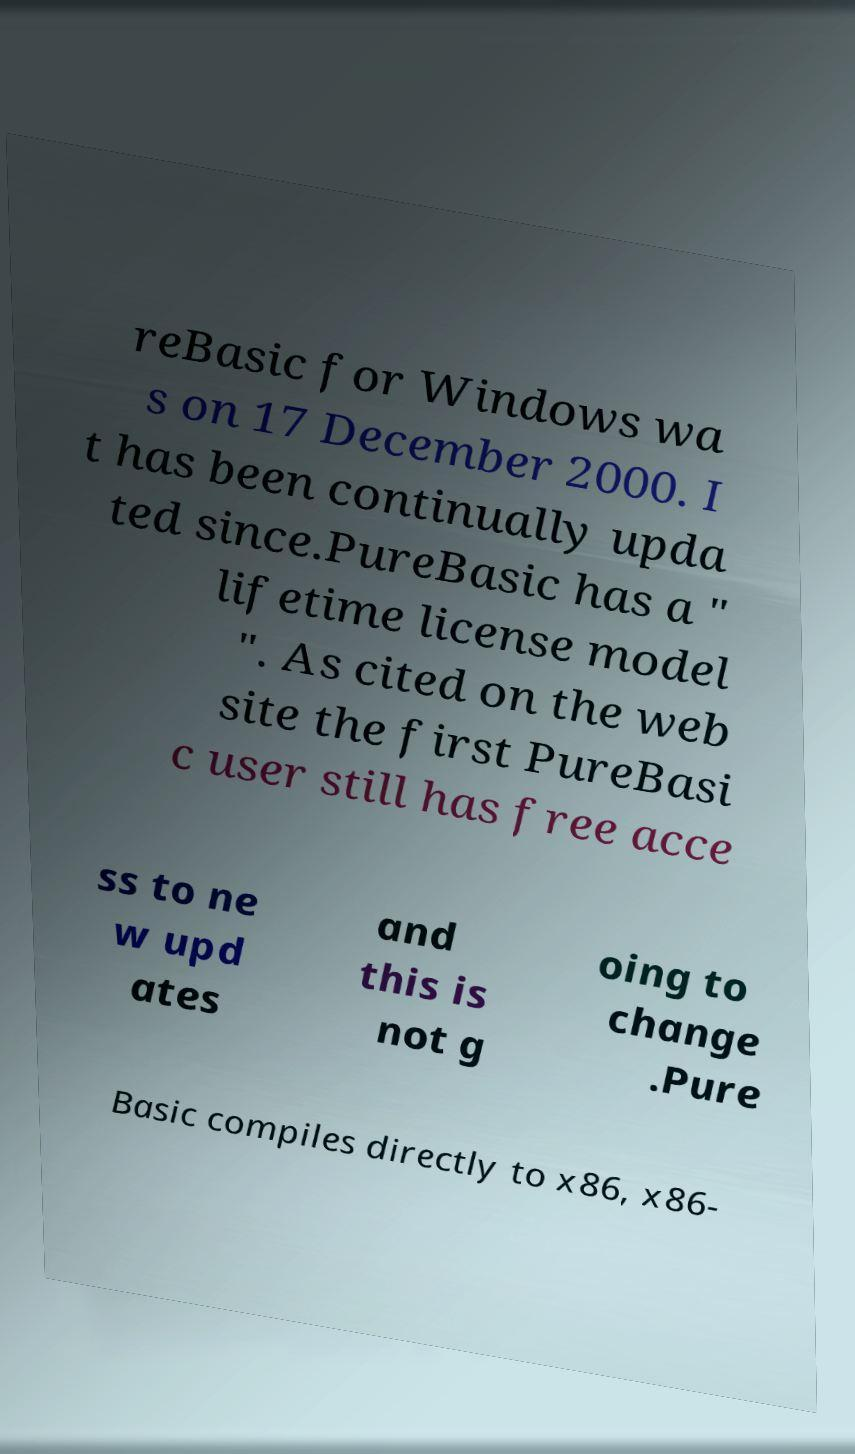Can you read and provide the text displayed in the image?This photo seems to have some interesting text. Can you extract and type it out for me? reBasic for Windows wa s on 17 December 2000. I t has been continually upda ted since.PureBasic has a " lifetime license model ". As cited on the web site the first PureBasi c user still has free acce ss to ne w upd ates and this is not g oing to change .Pure Basic compiles directly to x86, x86- 